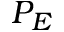Convert formula to latex. <formula><loc_0><loc_0><loc_500><loc_500>P _ { E }</formula> 